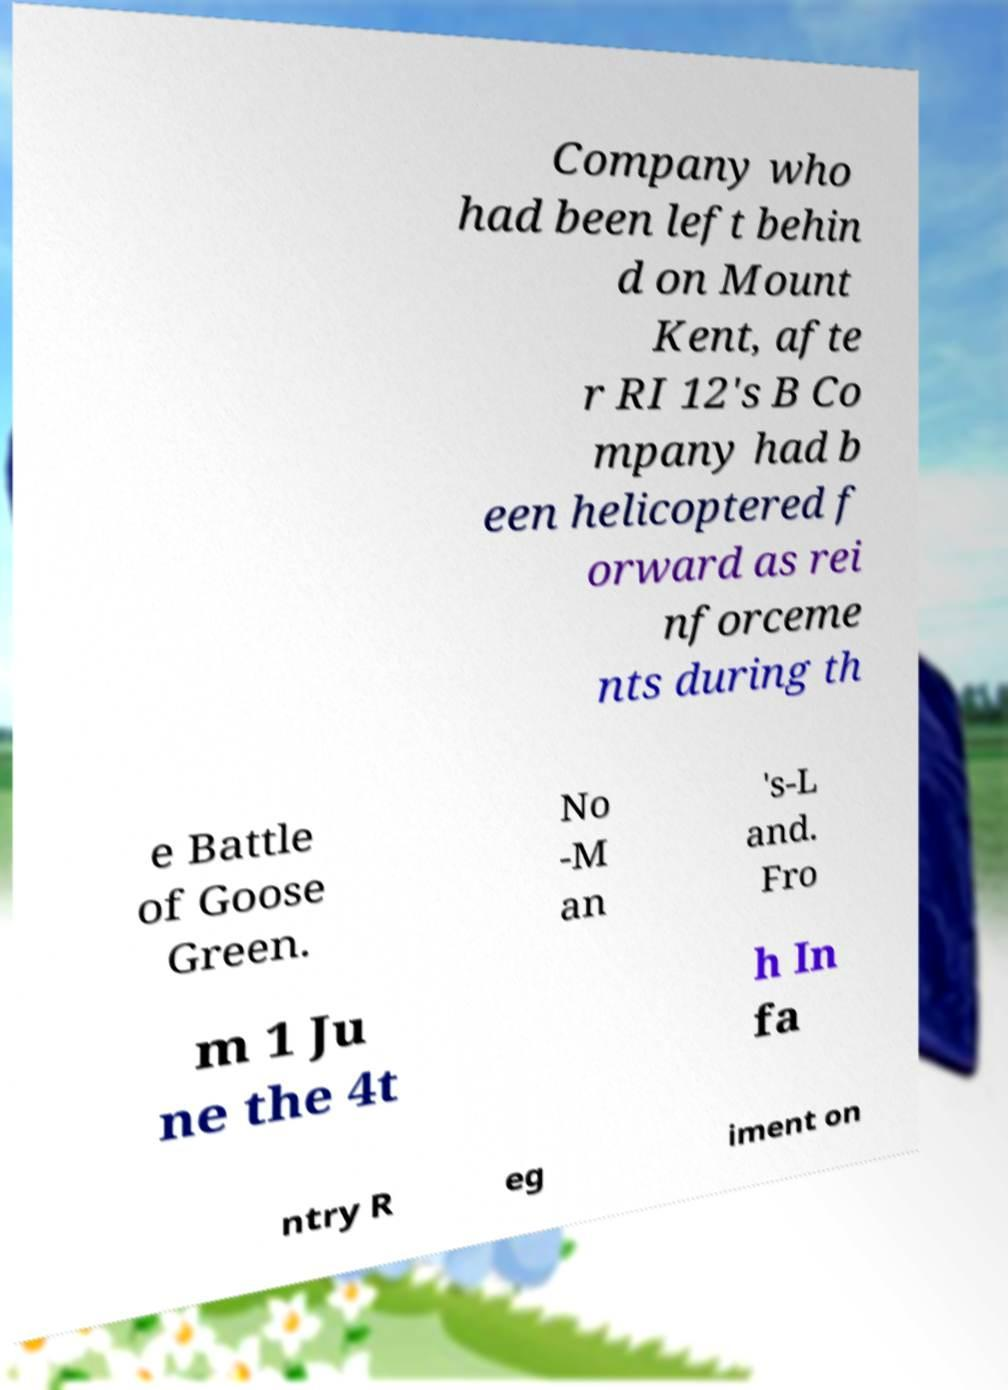Can you read and provide the text displayed in the image?This photo seems to have some interesting text. Can you extract and type it out for me? Company who had been left behin d on Mount Kent, afte r RI 12's B Co mpany had b een helicoptered f orward as rei nforceme nts during th e Battle of Goose Green. No -M an 's-L and. Fro m 1 Ju ne the 4t h In fa ntry R eg iment on 